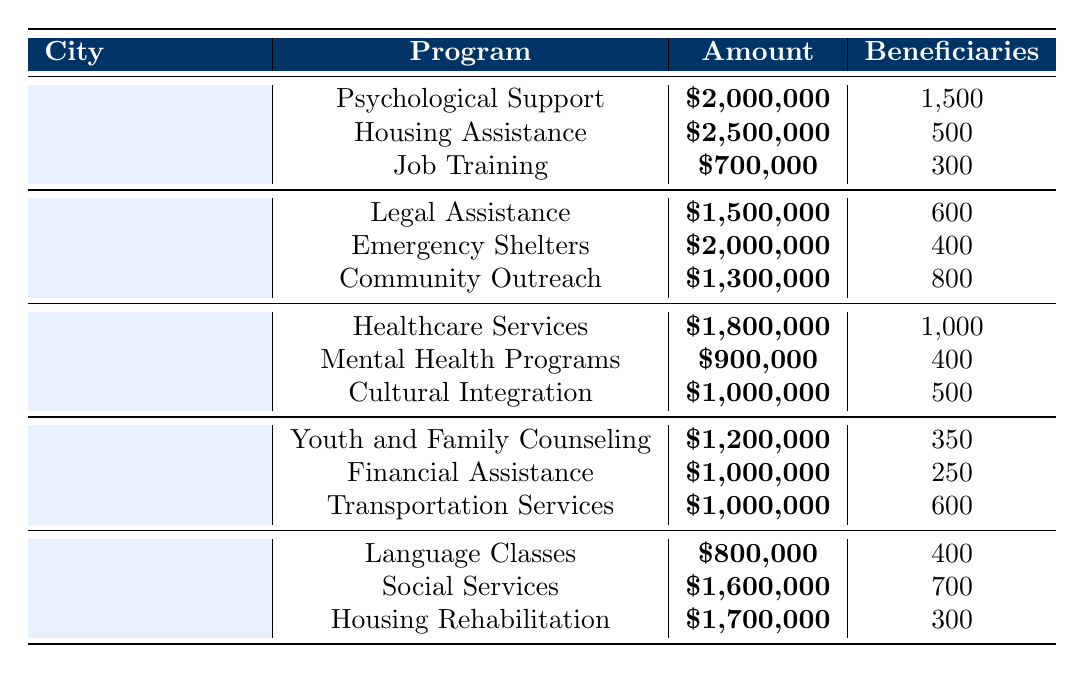What is the total funding allocated to Los Angeles for war survivor assistance? According to the table, the total amount allocated for war survivor assistance in Los Angeles is directly stated as **$5,200,000**.
Answer: $5,200,000 How much funding is allocated for Housing Assistance in New York City? In the column for New York City, the row for Housing Assistance shows an amount of **$2,000,000** allocated.
Answer: $2,000,000 Which program has the highest allocation in Chicago? By comparing the amounts allocated for all programs in Chicago, it can be seen that **Youth and Family Counseling** has the highest allocation of **$1,200,000**.
Answer: Youth and Family Counseling What is the total number of beneficiaries for all programs in Miami? The beneficiaries for the programs in Miami are 400 for Language Classes, 700 for Social Services, and 300 for Housing Rehabilitation. Adding these gives: 400 + 700 + 300 = 1400.
Answer: 1400 Which city received more funding: Houston or Illinois? Comparing total amounts, Houston received **$3,700,000** and Illinois received **$3,200,000**. Since **$3,700,000** is greater, Houston received more.
Answer: Houston What is the average amount allocated for each program in Los Angeles? The total amount allocated to programs in Los Angeles is **$5,200,000**. There are 3 programs, so the average is **$5,200,000 / 3 = $1,733,333.33**.
Answer: $1,733,333.33 Did Miami allocate more funding for Social Services or Housing Rehabilitation? The amount allocated for Social Services is **$1,600,000**, while for Housing Rehabilitation it is **$1,700,000**. Since **$1,700,000** is greater, Miami allocated more for Housing Rehabilitation.
Answer: Yes, for Housing Rehabilitation What is the total funding allocated for all programs in Texas? The total funding for Texas is the sum of Healthcare Services ($1,800,000), Mental Health Programs ($900,000), and Cultural Integration Workshops ($1,000,000). Adding these gives **$3,700,000**.
Answer: $3,700,000 Which program in New York City serves the most beneficiaries? In New York City, the program with the highest number of beneficiaries is Community Outreach and Education with **800** beneficiaries.
Answer: Community Outreach and Education If we compare the funding allocated for Job Training and Employment and Housing Rehabilitation, which one is higher? Job Training and Employment is allocated **$700,000** while Housing Rehabilitation in Miami is allocated **$1,700,000**. Since **$1,700,000** is greater, Housing Rehabilitation is higher.
Answer: Housing Rehabilitation 